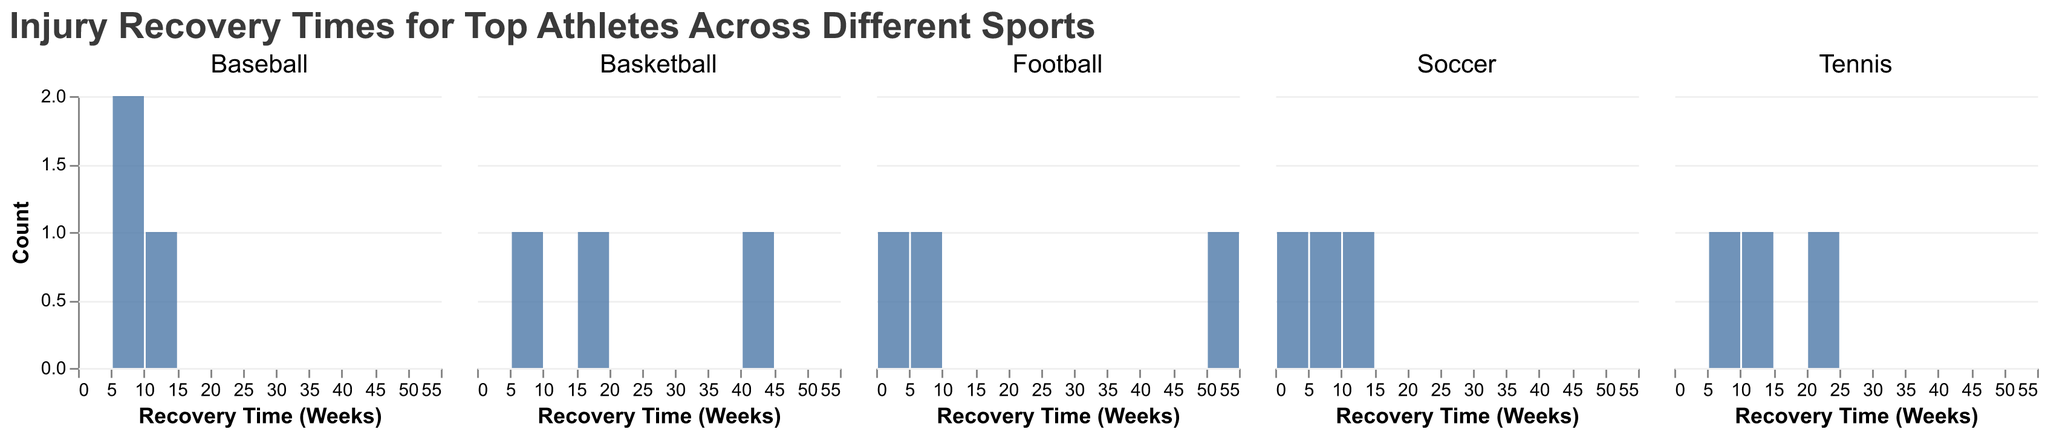What is the title of the figure? The title of the figure is generally located at the top and it summarizes the main topic or the data being visualized. In this figure, the title is "Injury Recovery Times for Top Athletes Across Different Sports".
Answer: Injury Recovery Times for Top Athletes Across Different Sports Which sport has the athlete with the longest recovery time? By examining the figure, you can identify which subplot contains the bar with the highest value in recovery time. The highest recovery time is 52 weeks, which belongs to the Football subplot.
Answer: Football How many athletes have a recovery time of 6 weeks? To answer this, look at the bars labeled "6" under the "Recovery Time (Weeks)" x-axis across all subplots and count the corresponding bars. There are two bars for 6 weeks: Cristiano Ronaldo in Soccer, Serena Williams in Tennis, and Clayton Kershaw in Baseball.
Answer: 3 Which athlete had the shortest recovery time in Football? Locate the Football subplot and identify the bar with the smallest value on the x-axis for recovery time. The shortest recovery time is 3 weeks, which belongs to Patrick Mahomes.
Answer: Patrick Mahomes What is the range of recovery times in Basketball? To find the range in the Basketball subplot, subtract the smallest recovery time (found on the leftmost bar) from the largest recovery time (rightmost bar). The smallest is 8 weeks, and the largest is 40 weeks. The range is 40 - 8 = 32 weeks.
Answer: 32 weeks Which sport has the most varied recovery times? This question requires comparing the differences between the minimum and maximum recovery times for all sports. Football (3-52 weeks) shows a larger range compared to other sports such as Soccer (4-12 weeks), Basketball (8-40 weeks), Tennis (6-24 weeks), and Baseball (6-12 weeks). Thus, Football has the most varied recovery times.
Answer: Football How many different injuries are represented in Tennis? By inspecting the bars in the Tennis subplot, each bar represents a different injury. The injuries listed are Hip Injury, Back Injury, and Knee Surgery, making a total of three different injuries.
Answer: 3 What is the average recovery time for Soccer players? Calculate the average by adding up the recovery times of all soccer players (6 + 4 + 12 = 22 weeks) and dividing by the number of players (3). The average recovery time is 22 / 3 = approximately 7.33 weeks.
Answer: approximately 7.33 weeks Which injury has the longest recovery time across all sports? Find the bar with the longest recovery time across all subplots. The bar with 52 weeks (ACL Tear) in the Football subplot representing Tom Brady's injury has the longest recovery time.
Answer: ACL Tear 